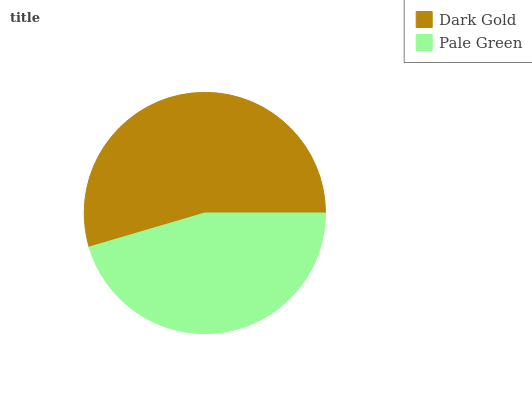Is Pale Green the minimum?
Answer yes or no. Yes. Is Dark Gold the maximum?
Answer yes or no. Yes. Is Pale Green the maximum?
Answer yes or no. No. Is Dark Gold greater than Pale Green?
Answer yes or no. Yes. Is Pale Green less than Dark Gold?
Answer yes or no. Yes. Is Pale Green greater than Dark Gold?
Answer yes or no. No. Is Dark Gold less than Pale Green?
Answer yes or no. No. Is Dark Gold the high median?
Answer yes or no. Yes. Is Pale Green the low median?
Answer yes or no. Yes. Is Pale Green the high median?
Answer yes or no. No. Is Dark Gold the low median?
Answer yes or no. No. 